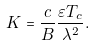<formula> <loc_0><loc_0><loc_500><loc_500>K = \frac { c } { B } \frac { \varepsilon T _ { c } } { \lambda ^ { 2 } } .</formula> 